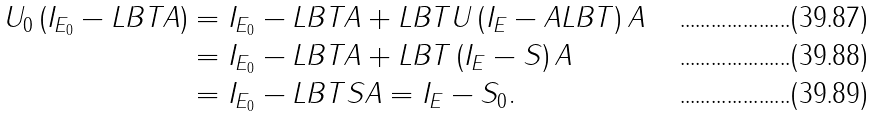Convert formula to latex. <formula><loc_0><loc_0><loc_500><loc_500>U _ { 0 } \left ( I _ { E _ { 0 } } - L B T A \right ) & = I _ { E _ { 0 } } - L B T A + L B T U \left ( I _ { E } - A L B T \right ) A \\ & = I _ { E _ { 0 } } - L B T A + L B T \left ( I _ { E } - S \right ) A \\ & = I _ { E _ { 0 } } - L B T S A = I _ { E } - S _ { 0 } .</formula> 